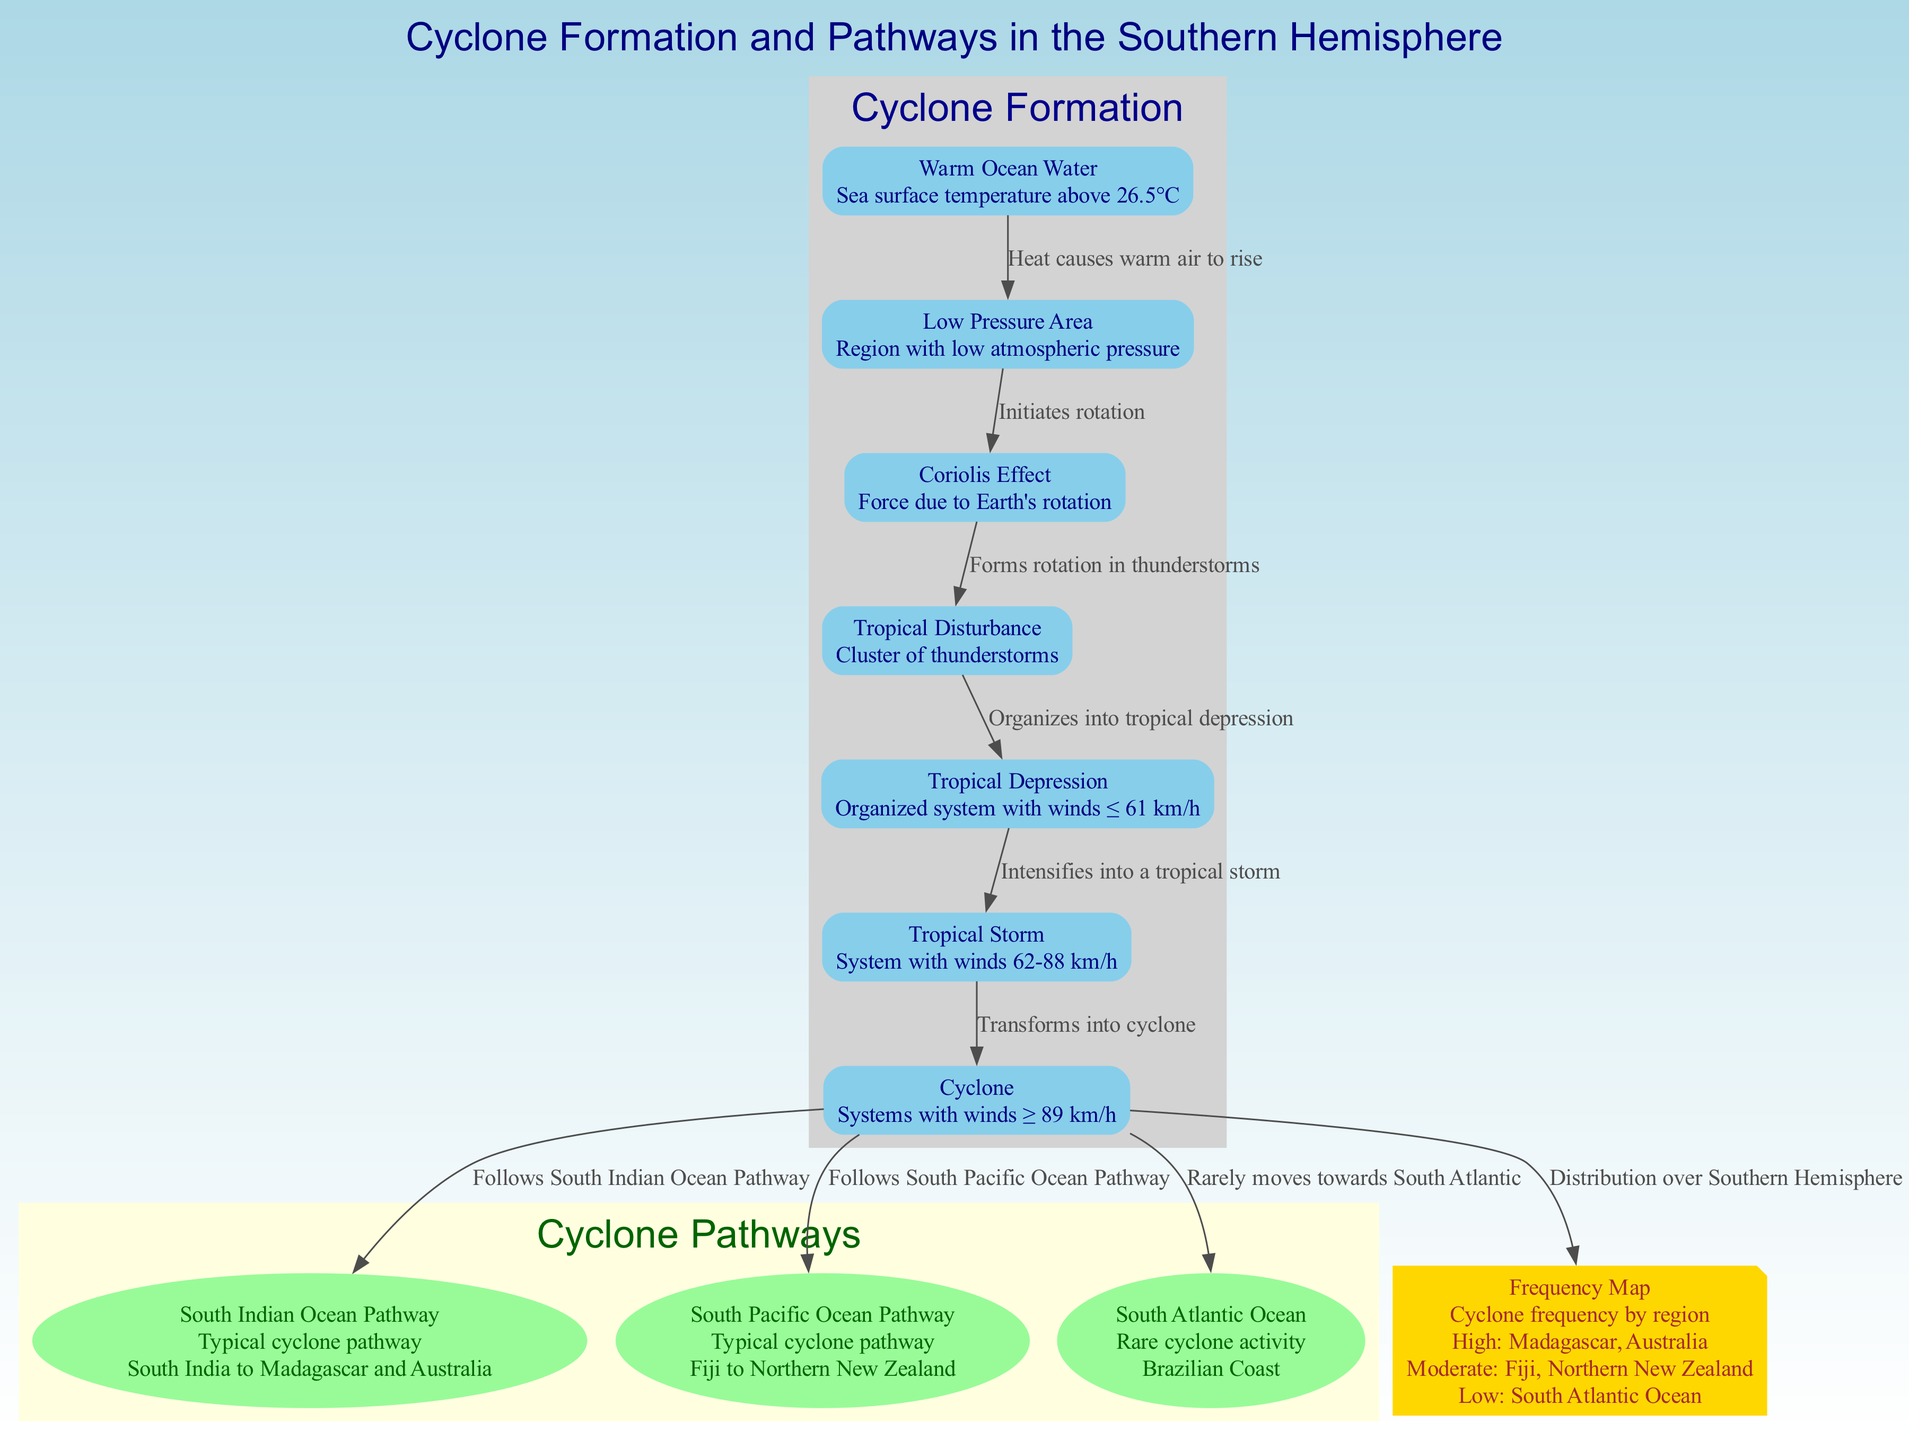What sea surface temperature is necessary for cyclone formation? The diagram shows "Warm Ocean Water" with a description that specifies sea surface temperature above 26.5°C as necessary for cyclone formation.
Answer: above 26.5°C What is the significant effect due to Earth's rotation shown in the diagram? The diagram lists "Coriolis Effect" as the significant effect due to Earth's rotation, indicating how it contributes to cyclone formation.
Answer: Coriolis Effect How many nodes are related to the cyclone formation process? The diagram identifies seven specific nodes related to the formation process from "Warm Ocean Water" to "Cyclone," confirming the total as seven nodes.
Answer: 7 Which pathway is associated with cyclones moving from South India to Australia? The "South Indian Ocean Pathway" node is specifically described as the pathway for cyclones moving from South India to Madagascar and Australia, providing its location context.
Answer: South Indian Ocean Pathway What is the pathway for cyclones that moves from Fiji to Northern New Zealand? The "South Pacific Ocean Pathway" node details that it is the pathway associated with cyclones moving from Fiji to Northern New Zealand.
Answer: South Pacific Ocean Pathway What follows a tropical storm in the cyclone formation process? The diagram outlines that a "Cyclone" follows after a "Tropical Storm" in the cyclone formation process, indicating the progression of the storm system.
Answer: Cyclone Which region has low cyclone frequency according to the frequency map? The "South Atlantic Ocean" is identified in the frequency map as a region with low cyclone activity, clearly reflected in the annotations of that node.
Answer: South Atlantic Ocean What condition is necessary for a storm to organize into a tropical depression? The transition from "Tropical Disturbance" to "Tropical Depression" in the diagram indicates that organization into a tropical depression follows after the formation of a cluster of thunderstorms.
Answer: Organized system with winds ≤ 61 km/h What happens to a tropical depression in terms of wind speeds as it intensifies? According to the flow of the diagram, a "Tropical Depression" intensifies into a "Tropical Storm" as wind speeds increase to between 62-88 km/h, illustrating the progression of the storm.
Answer: Winds 62-88 km/h 